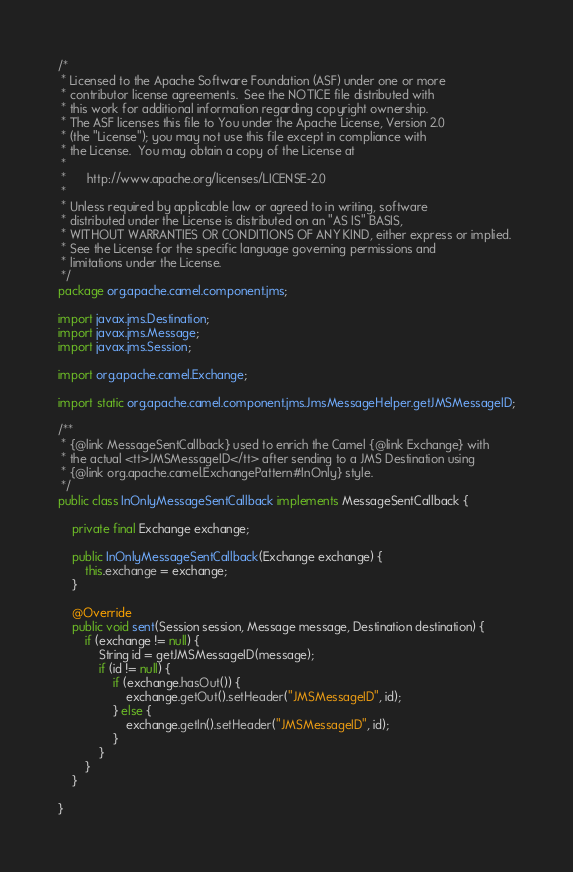Convert code to text. <code><loc_0><loc_0><loc_500><loc_500><_Java_>/*
 * Licensed to the Apache Software Foundation (ASF) under one or more
 * contributor license agreements.  See the NOTICE file distributed with
 * this work for additional information regarding copyright ownership.
 * The ASF licenses this file to You under the Apache License, Version 2.0
 * (the "License"); you may not use this file except in compliance with
 * the License.  You may obtain a copy of the License at
 *
 *      http://www.apache.org/licenses/LICENSE-2.0
 *
 * Unless required by applicable law or agreed to in writing, software
 * distributed under the License is distributed on an "AS IS" BASIS,
 * WITHOUT WARRANTIES OR CONDITIONS OF ANY KIND, either express or implied.
 * See the License for the specific language governing permissions and
 * limitations under the License.
 */
package org.apache.camel.component.jms;

import javax.jms.Destination;
import javax.jms.Message;
import javax.jms.Session;

import org.apache.camel.Exchange;

import static org.apache.camel.component.jms.JmsMessageHelper.getJMSMessageID;

/**
 * {@link MessageSentCallback} used to enrich the Camel {@link Exchange} with
 * the actual <tt>JMSMessageID</tt> after sending to a JMS Destination using
 * {@link org.apache.camel.ExchangePattern#InOnly} style.
 */
public class InOnlyMessageSentCallback implements MessageSentCallback {

    private final Exchange exchange;

    public InOnlyMessageSentCallback(Exchange exchange) {
        this.exchange = exchange;
    }

    @Override
    public void sent(Session session, Message message, Destination destination) {
        if (exchange != null) {
            String id = getJMSMessageID(message);
            if (id != null) {
                if (exchange.hasOut()) {
                    exchange.getOut().setHeader("JMSMessageID", id);
                } else {
                    exchange.getIn().setHeader("JMSMessageID", id);
                }
            }
        }
    }

}
</code> 